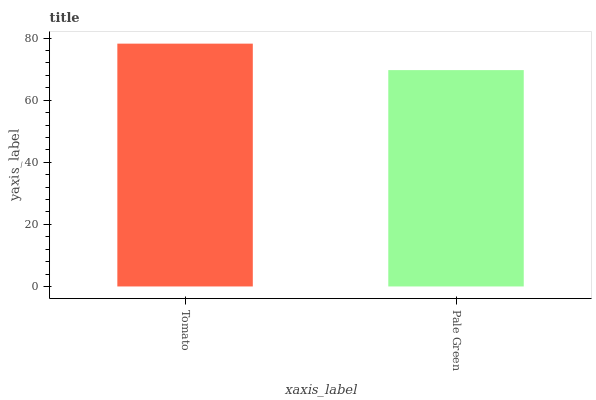Is Pale Green the minimum?
Answer yes or no. Yes. Is Tomato the maximum?
Answer yes or no. Yes. Is Pale Green the maximum?
Answer yes or no. No. Is Tomato greater than Pale Green?
Answer yes or no. Yes. Is Pale Green less than Tomato?
Answer yes or no. Yes. Is Pale Green greater than Tomato?
Answer yes or no. No. Is Tomato less than Pale Green?
Answer yes or no. No. Is Tomato the high median?
Answer yes or no. Yes. Is Pale Green the low median?
Answer yes or no. Yes. Is Pale Green the high median?
Answer yes or no. No. Is Tomato the low median?
Answer yes or no. No. 